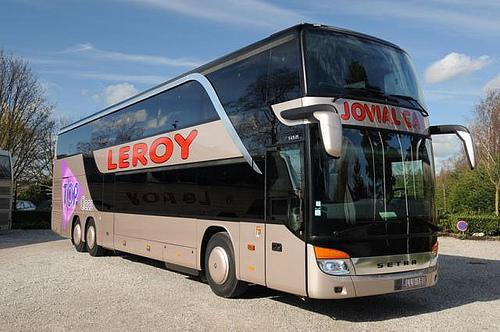Question: where is the bus parked?
Choices:
A. In a garage.
B. In a parking lot.
C. A sidewalk.
D. In a lot.
Answer with the letter. Answer: D Question: when was the picture taken?
Choices:
A. Daylight.
B. During the day.
C. Nighttime.
D. Evening.
Answer with the letter. Answer: B Question: who is standing by the bus?
Choices:
A. No one.
B. A girl.
C. A boy.
D. A man.
Answer with the letter. Answer: A 